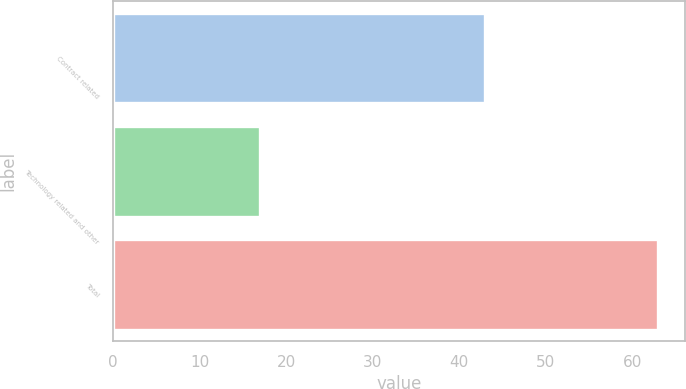Convert chart to OTSL. <chart><loc_0><loc_0><loc_500><loc_500><bar_chart><fcel>Contract related<fcel>Technology related and other<fcel>Total<nl><fcel>43<fcel>17<fcel>63<nl></chart> 